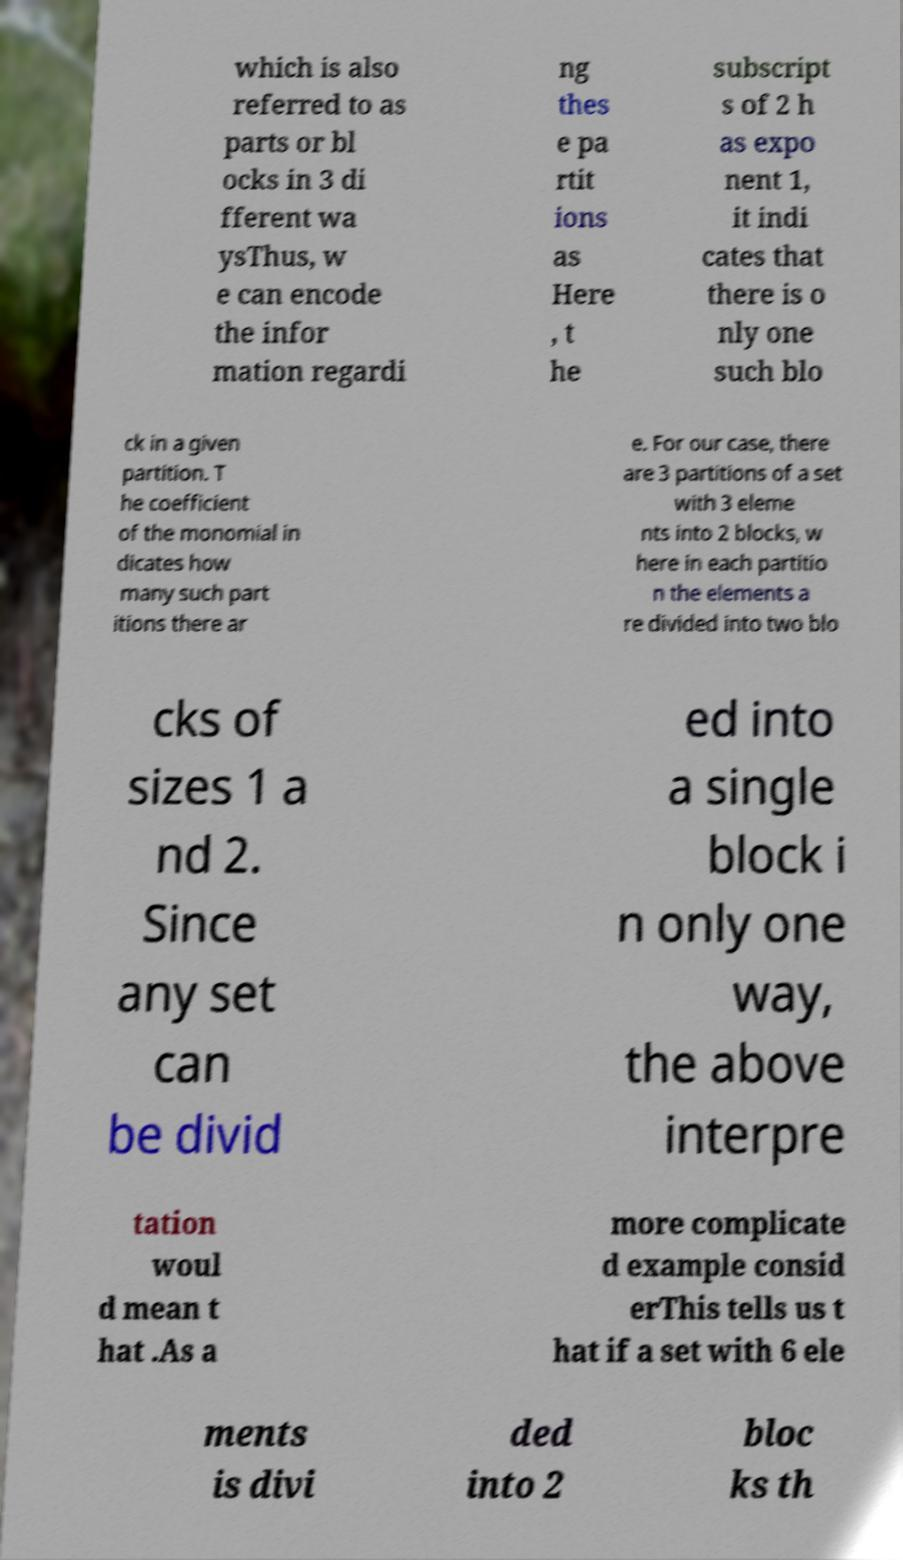There's text embedded in this image that I need extracted. Can you transcribe it verbatim? which is also referred to as parts or bl ocks in 3 di fferent wa ysThus, w e can encode the infor mation regardi ng thes e pa rtit ions as Here , t he subscript s of 2 h as expo nent 1, it indi cates that there is o nly one such blo ck in a given partition. T he coefficient of the monomial in dicates how many such part itions there ar e. For our case, there are 3 partitions of a set with 3 eleme nts into 2 blocks, w here in each partitio n the elements a re divided into two blo cks of sizes 1 a nd 2. Since any set can be divid ed into a single block i n only one way, the above interpre tation woul d mean t hat .As a more complicate d example consid erThis tells us t hat if a set with 6 ele ments is divi ded into 2 bloc ks th 